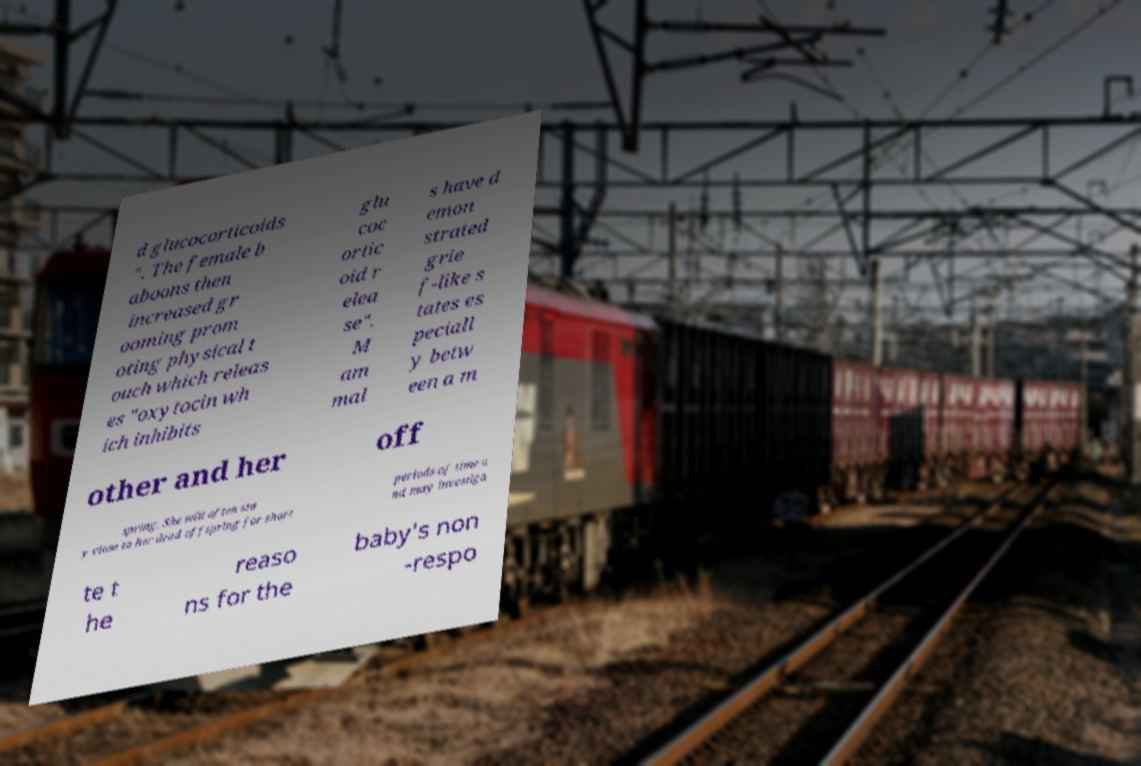There's text embedded in this image that I need extracted. Can you transcribe it verbatim? d glucocorticoids ". The female b aboons then increased gr ooming prom oting physical t ouch which releas es "oxytocin wh ich inhibits glu coc ortic oid r elea se". M am mal s have d emon strated grie f-like s tates es peciall y betw een a m other and her off spring. She will often sta y close to her dead offspring for short periods of time a nd may investiga te t he reaso ns for the baby's non -respo 